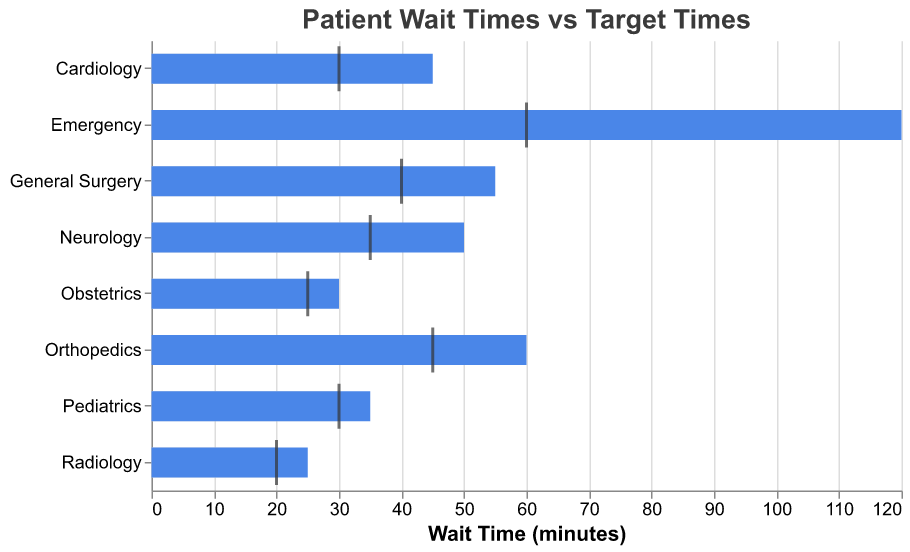What is the longest actual wait time among all the departments? By looking at the blue bars in the figure, we see that the Emergency department has the longest actual wait time, which is 120 minutes.
Answer: 120 minutes Which department has the shortest target wait time? By inspecting the grey bars and the tick marks, it is clear that the Radiology department has the shortest target wait time, which is 20 minutes.
Answer: Radiology How much longer is the actual wait time compared to the target wait time for the Emergency department? The Emergency department has an actual wait time of 120 minutes and a target wait time of 60 minutes. The difference is 120 - 60 = 60 minutes.
Answer: 60 minutes Which department's actual wait time is closest to its target wait time? Comparing all the departments, the Obstetrics department has an actual wait time of 30 minutes and a target wait time of 25 minutes, resulting in a difference of only 5 minutes, which is the smallest difference among all departments.
Answer: Obstetrics List the departments with an actual wait time exceeding their target wait time by more than 50%. To determine this, calculate 50% of the target wait time for each department and compare it to the actual wait time. The Emergency department (actual 120 mins, target 60 mins, 50% of 60 = 30) exceeds by more than 50%; no other department has such a large exceedance.
Answer: Emergency What is the average target wait time across all departments? Add the target wait times (60 + 30 + 30 + 45 + 20 + 40 + 35 + 25) and divide by the number of departments (8): (60+30+30+45+20+40+35+25)/8 = 285/8 = 35.625 minutes.
Answer: 35.625 minutes Which department has the largest difference between its actual and target wait times? Calculating the differences for each department, the largest difference of 60 minutes is found in the Emergency department (120 - 60 = 60).
Answer: Emergency Are there any departments where the actual wait time is less than the target wait time? All actual wait times (blue) exceed or are equal to the target wait times (grey); no department has an actual wait time less than its target wait time.
Answer: No 